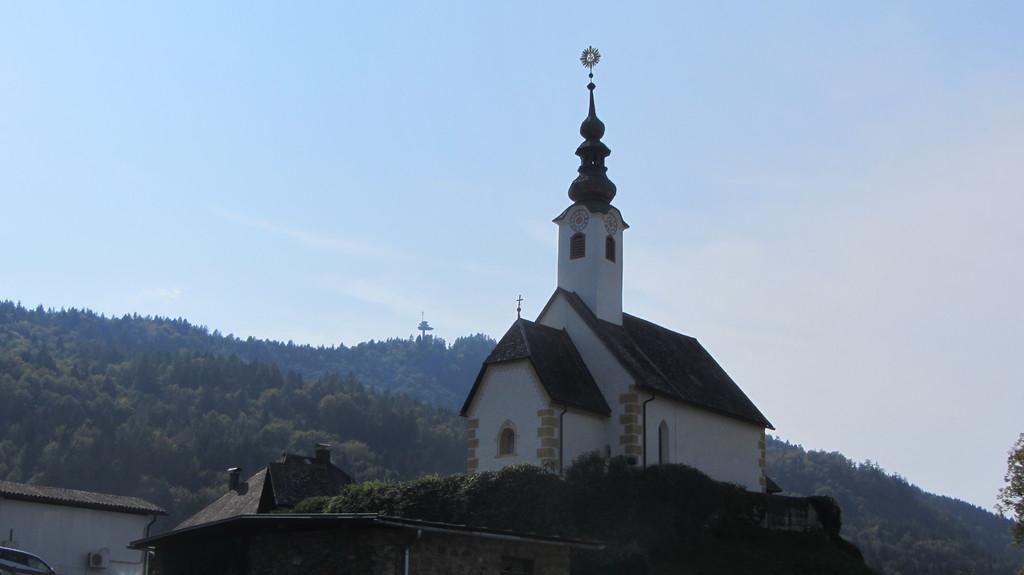Describe this image in one or two sentences. In this image I can see a building in white and brown color. Background I can see trees in green color and sky in blue color. 